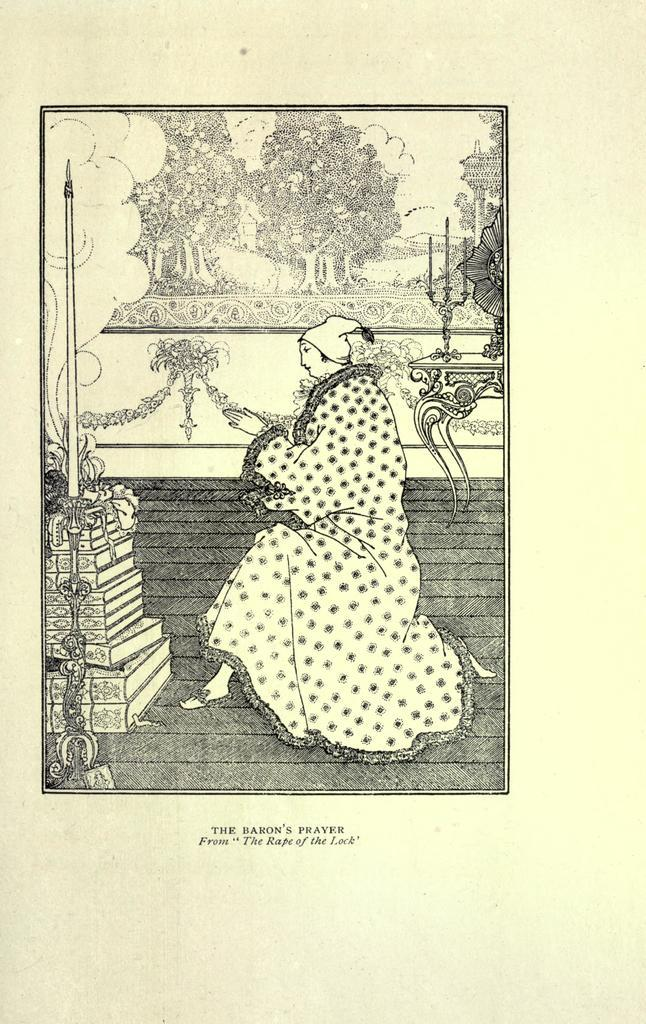What is depicted on the paper in the image? There is a person depicted on the paper in the image. What other items can be seen in the image besides the paper? There are books, a table, candles, a frame, a wall, and a floor visible in the image. What might be used for illumination in the image? Candles can be used for illumination in the image. What is the purpose of the frame in the image? The frame in the image is likely used for displaying or protecting the paper with the person depicted on it. Where is the straw located in the image? There is no straw present in the image. What type of amusement can be seen in the image? There is no amusement depicted in the image; it features a paper with a person, books, a table, candles, a frame, a wall, and a floor. 